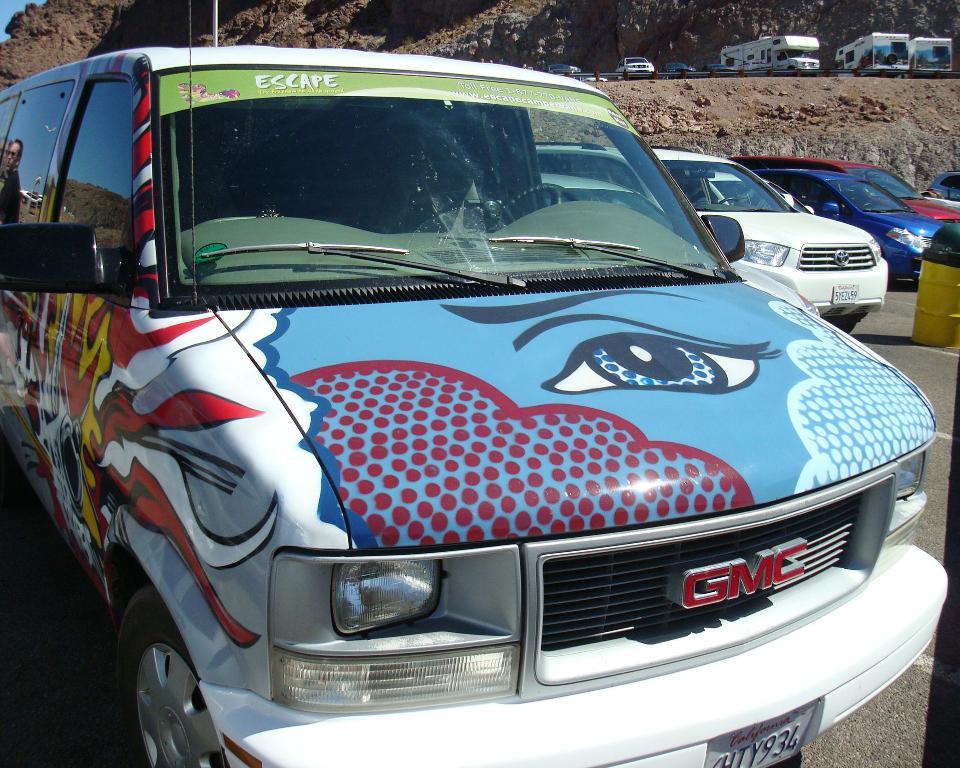What word is found on the van's windshield?
Offer a very short reply. Escape. What brand of van is this?
Provide a succinct answer. Gmc. 